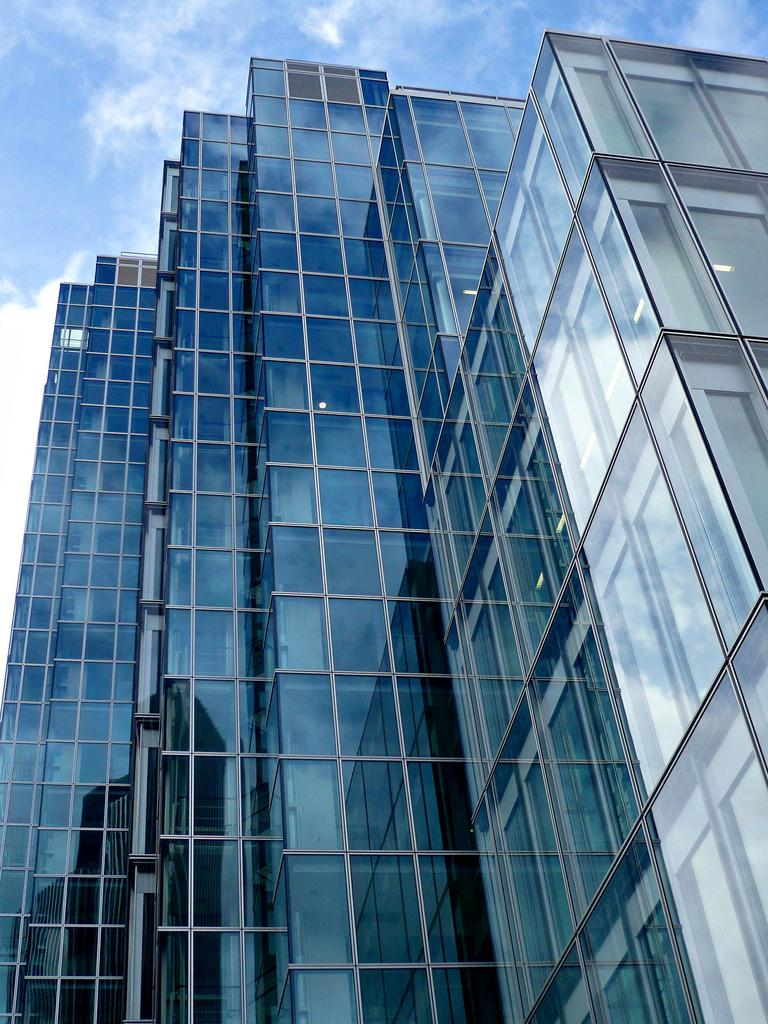What type of buildings are visible in the image? There are glass buildings in the image. What is visible at the top of the image? The sky is visible at the top of the image. Where is the school located in the image? There is no school present in the image; it only features glass buildings. What type of cub can be seen on the shelf in the image? There is no shelf or cub present in the image. 